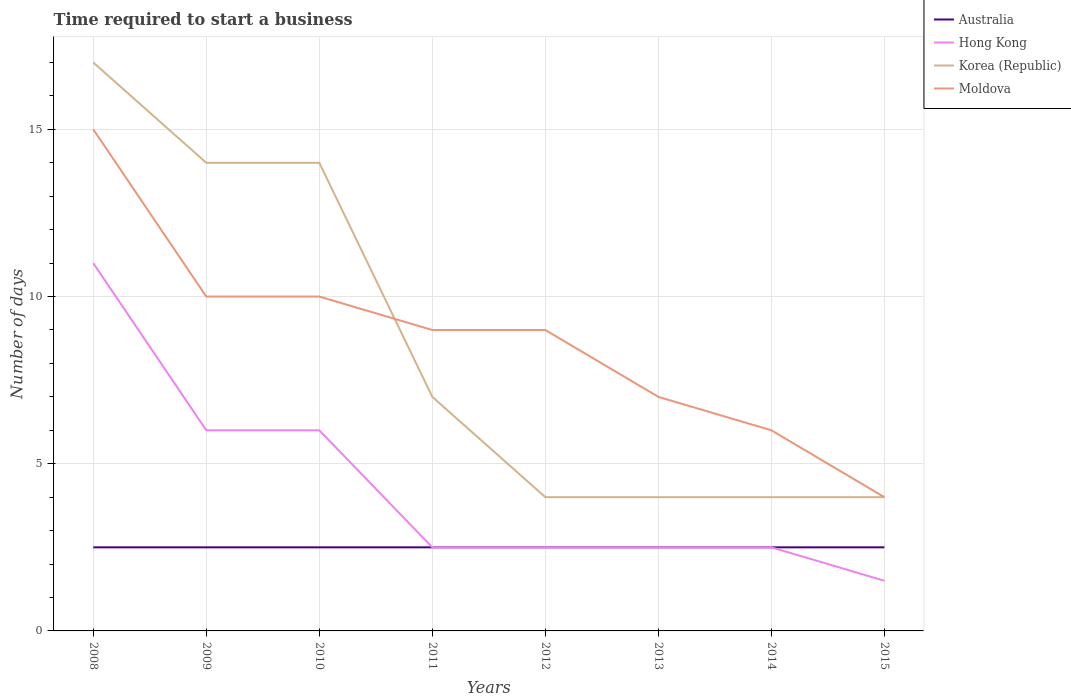Across all years, what is the maximum number of days required to start a business in Korea (Republic)?
Your response must be concise. 4. In which year was the number of days required to start a business in Hong Kong maximum?
Offer a very short reply. 2015. What is the total number of days required to start a business in Hong Kong in the graph?
Give a very brief answer. 1. What is the difference between the highest and the second highest number of days required to start a business in Moldova?
Provide a short and direct response. 11. How many lines are there?
Keep it short and to the point. 4. How many years are there in the graph?
Provide a succinct answer. 8. Are the values on the major ticks of Y-axis written in scientific E-notation?
Provide a short and direct response. No. Does the graph contain grids?
Your answer should be compact. Yes. Where does the legend appear in the graph?
Provide a short and direct response. Top right. What is the title of the graph?
Your answer should be compact. Time required to start a business. What is the label or title of the Y-axis?
Your answer should be very brief. Number of days. What is the Number of days of Australia in 2008?
Provide a short and direct response. 2.5. What is the Number of days of Korea (Republic) in 2008?
Ensure brevity in your answer.  17. What is the Number of days in Moldova in 2008?
Your answer should be very brief. 15. What is the Number of days in Korea (Republic) in 2009?
Offer a terse response. 14. What is the Number of days in Moldova in 2009?
Make the answer very short. 10. What is the Number of days in Australia in 2010?
Keep it short and to the point. 2.5. What is the Number of days of Korea (Republic) in 2010?
Keep it short and to the point. 14. What is the Number of days in Moldova in 2010?
Give a very brief answer. 10. What is the Number of days of Australia in 2011?
Offer a very short reply. 2.5. What is the Number of days in Hong Kong in 2011?
Your answer should be compact. 2.5. What is the Number of days in Korea (Republic) in 2011?
Your answer should be compact. 7. What is the Number of days in Moldova in 2011?
Make the answer very short. 9. What is the Number of days in Australia in 2012?
Make the answer very short. 2.5. What is the Number of days in Hong Kong in 2012?
Give a very brief answer. 2.5. What is the Number of days of Moldova in 2013?
Give a very brief answer. 7. What is the Number of days of Korea (Republic) in 2014?
Make the answer very short. 4. What is the Number of days of Hong Kong in 2015?
Make the answer very short. 1.5. What is the Number of days of Korea (Republic) in 2015?
Ensure brevity in your answer.  4. What is the Number of days in Moldova in 2015?
Keep it short and to the point. 4. Across all years, what is the maximum Number of days in Australia?
Your response must be concise. 2.5. Across all years, what is the maximum Number of days of Moldova?
Your answer should be compact. 15. Across all years, what is the minimum Number of days of Hong Kong?
Ensure brevity in your answer.  1.5. What is the total Number of days of Hong Kong in the graph?
Your answer should be very brief. 34.5. What is the total Number of days of Moldova in the graph?
Provide a succinct answer. 70. What is the difference between the Number of days in Moldova in 2008 and that in 2009?
Ensure brevity in your answer.  5. What is the difference between the Number of days in Korea (Republic) in 2008 and that in 2010?
Provide a succinct answer. 3. What is the difference between the Number of days in Korea (Republic) in 2008 and that in 2011?
Your answer should be compact. 10. What is the difference between the Number of days in Moldova in 2008 and that in 2011?
Your response must be concise. 6. What is the difference between the Number of days of Australia in 2008 and that in 2012?
Provide a succinct answer. 0. What is the difference between the Number of days of Moldova in 2008 and that in 2012?
Provide a succinct answer. 6. What is the difference between the Number of days of Australia in 2008 and that in 2013?
Provide a succinct answer. 0. What is the difference between the Number of days of Australia in 2008 and that in 2014?
Offer a terse response. 0. What is the difference between the Number of days in Hong Kong in 2008 and that in 2014?
Your answer should be very brief. 8.5. What is the difference between the Number of days in Korea (Republic) in 2008 and that in 2014?
Your answer should be very brief. 13. What is the difference between the Number of days of Australia in 2008 and that in 2015?
Your response must be concise. 0. What is the difference between the Number of days of Hong Kong in 2008 and that in 2015?
Make the answer very short. 9.5. What is the difference between the Number of days in Australia in 2009 and that in 2010?
Your answer should be compact. 0. What is the difference between the Number of days in Korea (Republic) in 2009 and that in 2010?
Give a very brief answer. 0. What is the difference between the Number of days in Moldova in 2009 and that in 2010?
Your answer should be compact. 0. What is the difference between the Number of days in Australia in 2009 and that in 2011?
Give a very brief answer. 0. What is the difference between the Number of days in Hong Kong in 2009 and that in 2011?
Make the answer very short. 3.5. What is the difference between the Number of days of Korea (Republic) in 2009 and that in 2011?
Offer a terse response. 7. What is the difference between the Number of days of Australia in 2009 and that in 2012?
Your response must be concise. 0. What is the difference between the Number of days of Hong Kong in 2009 and that in 2012?
Ensure brevity in your answer.  3.5. What is the difference between the Number of days of Korea (Republic) in 2009 and that in 2012?
Your answer should be very brief. 10. What is the difference between the Number of days of Hong Kong in 2009 and that in 2013?
Give a very brief answer. 3.5. What is the difference between the Number of days of Moldova in 2009 and that in 2013?
Make the answer very short. 3. What is the difference between the Number of days of Australia in 2009 and that in 2014?
Offer a terse response. 0. What is the difference between the Number of days in Korea (Republic) in 2009 and that in 2014?
Offer a very short reply. 10. What is the difference between the Number of days of Moldova in 2009 and that in 2014?
Your answer should be very brief. 4. What is the difference between the Number of days of Hong Kong in 2010 and that in 2012?
Your answer should be compact. 3.5. What is the difference between the Number of days of Moldova in 2010 and that in 2012?
Offer a terse response. 1. What is the difference between the Number of days in Korea (Republic) in 2010 and that in 2013?
Keep it short and to the point. 10. What is the difference between the Number of days in Moldova in 2010 and that in 2013?
Keep it short and to the point. 3. What is the difference between the Number of days in Australia in 2010 and that in 2014?
Your answer should be very brief. 0. What is the difference between the Number of days in Hong Kong in 2010 and that in 2014?
Your answer should be compact. 3.5. What is the difference between the Number of days of Korea (Republic) in 2010 and that in 2014?
Ensure brevity in your answer.  10. What is the difference between the Number of days in Australia in 2010 and that in 2015?
Keep it short and to the point. 0. What is the difference between the Number of days of Moldova in 2010 and that in 2015?
Your response must be concise. 6. What is the difference between the Number of days of Korea (Republic) in 2011 and that in 2013?
Provide a succinct answer. 3. What is the difference between the Number of days of Korea (Republic) in 2011 and that in 2014?
Provide a succinct answer. 3. What is the difference between the Number of days of Australia in 2011 and that in 2015?
Provide a succinct answer. 0. What is the difference between the Number of days in Hong Kong in 2011 and that in 2015?
Your response must be concise. 1. What is the difference between the Number of days of Korea (Republic) in 2011 and that in 2015?
Offer a terse response. 3. What is the difference between the Number of days of Australia in 2012 and that in 2013?
Provide a short and direct response. 0. What is the difference between the Number of days in Hong Kong in 2012 and that in 2013?
Provide a short and direct response. 0. What is the difference between the Number of days of Moldova in 2012 and that in 2013?
Your answer should be very brief. 2. What is the difference between the Number of days in Hong Kong in 2012 and that in 2014?
Your answer should be compact. 0. What is the difference between the Number of days of Korea (Republic) in 2012 and that in 2014?
Provide a succinct answer. 0. What is the difference between the Number of days of Moldova in 2012 and that in 2014?
Provide a succinct answer. 3. What is the difference between the Number of days in Korea (Republic) in 2012 and that in 2015?
Provide a succinct answer. 0. What is the difference between the Number of days in Hong Kong in 2013 and that in 2014?
Offer a terse response. 0. What is the difference between the Number of days in Korea (Republic) in 2013 and that in 2014?
Provide a succinct answer. 0. What is the difference between the Number of days of Moldova in 2013 and that in 2014?
Make the answer very short. 1. What is the difference between the Number of days in Korea (Republic) in 2013 and that in 2015?
Your response must be concise. 0. What is the difference between the Number of days of Moldova in 2013 and that in 2015?
Offer a very short reply. 3. What is the difference between the Number of days of Australia in 2014 and that in 2015?
Provide a succinct answer. 0. What is the difference between the Number of days in Korea (Republic) in 2014 and that in 2015?
Provide a succinct answer. 0. What is the difference between the Number of days of Australia in 2008 and the Number of days of Hong Kong in 2009?
Offer a very short reply. -3.5. What is the difference between the Number of days of Australia in 2008 and the Number of days of Korea (Republic) in 2009?
Offer a very short reply. -11.5. What is the difference between the Number of days of Hong Kong in 2008 and the Number of days of Moldova in 2009?
Keep it short and to the point. 1. What is the difference between the Number of days of Korea (Republic) in 2008 and the Number of days of Moldova in 2009?
Your answer should be very brief. 7. What is the difference between the Number of days of Australia in 2008 and the Number of days of Hong Kong in 2010?
Make the answer very short. -3.5. What is the difference between the Number of days in Australia in 2008 and the Number of days in Korea (Republic) in 2010?
Offer a very short reply. -11.5. What is the difference between the Number of days in Australia in 2008 and the Number of days in Moldova in 2010?
Give a very brief answer. -7.5. What is the difference between the Number of days of Hong Kong in 2008 and the Number of days of Korea (Republic) in 2010?
Provide a short and direct response. -3. What is the difference between the Number of days in Hong Kong in 2008 and the Number of days in Moldova in 2010?
Your answer should be very brief. 1. What is the difference between the Number of days in Australia in 2008 and the Number of days in Korea (Republic) in 2011?
Keep it short and to the point. -4.5. What is the difference between the Number of days in Australia in 2008 and the Number of days in Moldova in 2011?
Provide a short and direct response. -6.5. What is the difference between the Number of days of Hong Kong in 2008 and the Number of days of Korea (Republic) in 2011?
Keep it short and to the point. 4. What is the difference between the Number of days of Australia in 2008 and the Number of days of Hong Kong in 2012?
Keep it short and to the point. 0. What is the difference between the Number of days in Australia in 2008 and the Number of days in Korea (Republic) in 2012?
Give a very brief answer. -1.5. What is the difference between the Number of days of Australia in 2008 and the Number of days of Moldova in 2012?
Your answer should be compact. -6.5. What is the difference between the Number of days of Korea (Republic) in 2008 and the Number of days of Moldova in 2012?
Offer a terse response. 8. What is the difference between the Number of days of Australia in 2008 and the Number of days of Moldova in 2013?
Provide a short and direct response. -4.5. What is the difference between the Number of days in Korea (Republic) in 2008 and the Number of days in Moldova in 2013?
Give a very brief answer. 10. What is the difference between the Number of days of Australia in 2008 and the Number of days of Moldova in 2014?
Provide a short and direct response. -3.5. What is the difference between the Number of days of Hong Kong in 2008 and the Number of days of Korea (Republic) in 2014?
Make the answer very short. 7. What is the difference between the Number of days in Korea (Republic) in 2008 and the Number of days in Moldova in 2014?
Provide a short and direct response. 11. What is the difference between the Number of days of Australia in 2008 and the Number of days of Korea (Republic) in 2015?
Offer a very short reply. -1.5. What is the difference between the Number of days in Australia in 2008 and the Number of days in Moldova in 2015?
Provide a short and direct response. -1.5. What is the difference between the Number of days of Hong Kong in 2008 and the Number of days of Korea (Republic) in 2015?
Give a very brief answer. 7. What is the difference between the Number of days of Australia in 2009 and the Number of days of Hong Kong in 2010?
Offer a terse response. -3.5. What is the difference between the Number of days in Australia in 2009 and the Number of days in Korea (Republic) in 2010?
Offer a very short reply. -11.5. What is the difference between the Number of days in Hong Kong in 2009 and the Number of days in Moldova in 2010?
Your answer should be very brief. -4. What is the difference between the Number of days in Australia in 2009 and the Number of days in Moldova in 2011?
Your answer should be very brief. -6.5. What is the difference between the Number of days in Hong Kong in 2009 and the Number of days in Moldova in 2011?
Provide a succinct answer. -3. What is the difference between the Number of days in Australia in 2009 and the Number of days in Hong Kong in 2012?
Your answer should be compact. 0. What is the difference between the Number of days of Australia in 2009 and the Number of days of Korea (Republic) in 2012?
Provide a short and direct response. -1.5. What is the difference between the Number of days of Australia in 2009 and the Number of days of Moldova in 2012?
Make the answer very short. -6.5. What is the difference between the Number of days of Korea (Republic) in 2009 and the Number of days of Moldova in 2012?
Your answer should be very brief. 5. What is the difference between the Number of days of Australia in 2009 and the Number of days of Hong Kong in 2013?
Your answer should be compact. 0. What is the difference between the Number of days of Australia in 2009 and the Number of days of Korea (Republic) in 2013?
Offer a terse response. -1.5. What is the difference between the Number of days of Hong Kong in 2009 and the Number of days of Moldova in 2013?
Provide a short and direct response. -1. What is the difference between the Number of days of Korea (Republic) in 2009 and the Number of days of Moldova in 2013?
Offer a terse response. 7. What is the difference between the Number of days of Australia in 2009 and the Number of days of Moldova in 2014?
Make the answer very short. -3.5. What is the difference between the Number of days in Hong Kong in 2009 and the Number of days in Korea (Republic) in 2014?
Your answer should be very brief. 2. What is the difference between the Number of days in Hong Kong in 2009 and the Number of days in Moldova in 2014?
Your response must be concise. 0. What is the difference between the Number of days of Australia in 2009 and the Number of days of Moldova in 2015?
Keep it short and to the point. -1.5. What is the difference between the Number of days of Hong Kong in 2009 and the Number of days of Korea (Republic) in 2015?
Make the answer very short. 2. What is the difference between the Number of days in Hong Kong in 2009 and the Number of days in Moldova in 2015?
Ensure brevity in your answer.  2. What is the difference between the Number of days in Australia in 2010 and the Number of days in Hong Kong in 2011?
Keep it short and to the point. 0. What is the difference between the Number of days in Australia in 2010 and the Number of days in Korea (Republic) in 2011?
Provide a succinct answer. -4.5. What is the difference between the Number of days of Australia in 2010 and the Number of days of Moldova in 2011?
Provide a short and direct response. -6.5. What is the difference between the Number of days in Korea (Republic) in 2010 and the Number of days in Moldova in 2011?
Provide a short and direct response. 5. What is the difference between the Number of days in Australia in 2010 and the Number of days in Hong Kong in 2012?
Give a very brief answer. 0. What is the difference between the Number of days in Australia in 2010 and the Number of days in Moldova in 2012?
Provide a short and direct response. -6.5. What is the difference between the Number of days in Hong Kong in 2010 and the Number of days in Korea (Republic) in 2012?
Give a very brief answer. 2. What is the difference between the Number of days in Korea (Republic) in 2010 and the Number of days in Moldova in 2012?
Your answer should be compact. 5. What is the difference between the Number of days in Australia in 2010 and the Number of days in Hong Kong in 2013?
Your answer should be very brief. 0. What is the difference between the Number of days of Australia in 2010 and the Number of days of Korea (Republic) in 2013?
Provide a short and direct response. -1.5. What is the difference between the Number of days of Hong Kong in 2010 and the Number of days of Moldova in 2013?
Your answer should be compact. -1. What is the difference between the Number of days in Korea (Republic) in 2010 and the Number of days in Moldova in 2013?
Your answer should be very brief. 7. What is the difference between the Number of days in Australia in 2010 and the Number of days in Korea (Republic) in 2015?
Your response must be concise. -1.5. What is the difference between the Number of days of Australia in 2010 and the Number of days of Moldova in 2015?
Offer a very short reply. -1.5. What is the difference between the Number of days in Australia in 2011 and the Number of days in Hong Kong in 2012?
Your answer should be very brief. 0. What is the difference between the Number of days in Korea (Republic) in 2011 and the Number of days in Moldova in 2012?
Offer a very short reply. -2. What is the difference between the Number of days in Australia in 2011 and the Number of days in Hong Kong in 2013?
Offer a terse response. 0. What is the difference between the Number of days of Hong Kong in 2011 and the Number of days of Moldova in 2013?
Your answer should be compact. -4.5. What is the difference between the Number of days of Australia in 2011 and the Number of days of Moldova in 2014?
Offer a terse response. -3.5. What is the difference between the Number of days in Korea (Republic) in 2011 and the Number of days in Moldova in 2014?
Your answer should be very brief. 1. What is the difference between the Number of days in Australia in 2011 and the Number of days in Hong Kong in 2015?
Give a very brief answer. 1. What is the difference between the Number of days of Australia in 2011 and the Number of days of Korea (Republic) in 2015?
Provide a short and direct response. -1.5. What is the difference between the Number of days of Australia in 2011 and the Number of days of Moldova in 2015?
Your answer should be very brief. -1.5. What is the difference between the Number of days of Hong Kong in 2011 and the Number of days of Korea (Republic) in 2015?
Keep it short and to the point. -1.5. What is the difference between the Number of days of Korea (Republic) in 2011 and the Number of days of Moldova in 2015?
Make the answer very short. 3. What is the difference between the Number of days of Australia in 2012 and the Number of days of Hong Kong in 2013?
Make the answer very short. 0. What is the difference between the Number of days of Hong Kong in 2012 and the Number of days of Korea (Republic) in 2013?
Your answer should be compact. -1.5. What is the difference between the Number of days in Korea (Republic) in 2012 and the Number of days in Moldova in 2013?
Make the answer very short. -3. What is the difference between the Number of days of Australia in 2012 and the Number of days of Hong Kong in 2014?
Keep it short and to the point. 0. What is the difference between the Number of days of Australia in 2012 and the Number of days of Moldova in 2014?
Offer a very short reply. -3.5. What is the difference between the Number of days of Hong Kong in 2012 and the Number of days of Korea (Republic) in 2014?
Offer a terse response. -1.5. What is the difference between the Number of days in Australia in 2012 and the Number of days in Hong Kong in 2015?
Your answer should be very brief. 1. What is the difference between the Number of days of Australia in 2012 and the Number of days of Korea (Republic) in 2015?
Offer a very short reply. -1.5. What is the difference between the Number of days in Hong Kong in 2012 and the Number of days in Moldova in 2015?
Ensure brevity in your answer.  -1.5. What is the difference between the Number of days of Korea (Republic) in 2012 and the Number of days of Moldova in 2015?
Provide a short and direct response. 0. What is the difference between the Number of days of Hong Kong in 2013 and the Number of days of Korea (Republic) in 2014?
Ensure brevity in your answer.  -1.5. What is the difference between the Number of days in Korea (Republic) in 2013 and the Number of days in Moldova in 2014?
Provide a short and direct response. -2. What is the difference between the Number of days in Australia in 2013 and the Number of days in Korea (Republic) in 2015?
Provide a succinct answer. -1.5. What is the difference between the Number of days in Australia in 2014 and the Number of days in Korea (Republic) in 2015?
Offer a terse response. -1.5. What is the difference between the Number of days in Australia in 2014 and the Number of days in Moldova in 2015?
Give a very brief answer. -1.5. What is the difference between the Number of days in Hong Kong in 2014 and the Number of days in Korea (Republic) in 2015?
Provide a succinct answer. -1.5. What is the difference between the Number of days of Korea (Republic) in 2014 and the Number of days of Moldova in 2015?
Your answer should be very brief. 0. What is the average Number of days in Hong Kong per year?
Keep it short and to the point. 4.31. What is the average Number of days of Korea (Republic) per year?
Your response must be concise. 8.5. What is the average Number of days in Moldova per year?
Offer a very short reply. 8.75. In the year 2008, what is the difference between the Number of days in Australia and Number of days in Moldova?
Offer a very short reply. -12.5. In the year 2009, what is the difference between the Number of days of Australia and Number of days of Korea (Republic)?
Keep it short and to the point. -11.5. In the year 2009, what is the difference between the Number of days in Hong Kong and Number of days in Korea (Republic)?
Offer a terse response. -8. In the year 2009, what is the difference between the Number of days in Hong Kong and Number of days in Moldova?
Your answer should be compact. -4. In the year 2010, what is the difference between the Number of days in Australia and Number of days in Hong Kong?
Ensure brevity in your answer.  -3.5. In the year 2010, what is the difference between the Number of days in Australia and Number of days in Korea (Republic)?
Provide a succinct answer. -11.5. In the year 2010, what is the difference between the Number of days of Australia and Number of days of Moldova?
Provide a short and direct response. -7.5. In the year 2010, what is the difference between the Number of days of Hong Kong and Number of days of Korea (Republic)?
Ensure brevity in your answer.  -8. In the year 2010, what is the difference between the Number of days in Hong Kong and Number of days in Moldova?
Ensure brevity in your answer.  -4. In the year 2010, what is the difference between the Number of days of Korea (Republic) and Number of days of Moldova?
Provide a short and direct response. 4. In the year 2011, what is the difference between the Number of days of Australia and Number of days of Korea (Republic)?
Keep it short and to the point. -4.5. In the year 2011, what is the difference between the Number of days in Australia and Number of days in Moldova?
Make the answer very short. -6.5. In the year 2011, what is the difference between the Number of days of Hong Kong and Number of days of Korea (Republic)?
Your answer should be compact. -4.5. In the year 2011, what is the difference between the Number of days of Korea (Republic) and Number of days of Moldova?
Your answer should be very brief. -2. In the year 2012, what is the difference between the Number of days of Australia and Number of days of Hong Kong?
Provide a short and direct response. 0. In the year 2012, what is the difference between the Number of days of Australia and Number of days of Korea (Republic)?
Offer a terse response. -1.5. In the year 2012, what is the difference between the Number of days in Hong Kong and Number of days in Korea (Republic)?
Provide a succinct answer. -1.5. In the year 2012, what is the difference between the Number of days in Hong Kong and Number of days in Moldova?
Offer a terse response. -6.5. In the year 2012, what is the difference between the Number of days of Korea (Republic) and Number of days of Moldova?
Make the answer very short. -5. In the year 2013, what is the difference between the Number of days in Australia and Number of days in Korea (Republic)?
Give a very brief answer. -1.5. In the year 2013, what is the difference between the Number of days in Hong Kong and Number of days in Korea (Republic)?
Provide a short and direct response. -1.5. In the year 2013, what is the difference between the Number of days in Korea (Republic) and Number of days in Moldova?
Offer a terse response. -3. In the year 2014, what is the difference between the Number of days of Australia and Number of days of Korea (Republic)?
Give a very brief answer. -1.5. In the year 2014, what is the difference between the Number of days in Australia and Number of days in Moldova?
Your answer should be compact. -3.5. In the year 2014, what is the difference between the Number of days in Hong Kong and Number of days in Moldova?
Your answer should be compact. -3.5. In the year 2015, what is the difference between the Number of days in Australia and Number of days in Hong Kong?
Your answer should be compact. 1. In the year 2015, what is the difference between the Number of days of Australia and Number of days of Moldova?
Give a very brief answer. -1.5. In the year 2015, what is the difference between the Number of days in Hong Kong and Number of days in Korea (Republic)?
Offer a terse response. -2.5. What is the ratio of the Number of days in Hong Kong in 2008 to that in 2009?
Your response must be concise. 1.83. What is the ratio of the Number of days of Korea (Republic) in 2008 to that in 2009?
Provide a succinct answer. 1.21. What is the ratio of the Number of days of Moldova in 2008 to that in 2009?
Your answer should be very brief. 1.5. What is the ratio of the Number of days in Hong Kong in 2008 to that in 2010?
Ensure brevity in your answer.  1.83. What is the ratio of the Number of days in Korea (Republic) in 2008 to that in 2010?
Give a very brief answer. 1.21. What is the ratio of the Number of days in Korea (Republic) in 2008 to that in 2011?
Make the answer very short. 2.43. What is the ratio of the Number of days in Moldova in 2008 to that in 2011?
Give a very brief answer. 1.67. What is the ratio of the Number of days in Australia in 2008 to that in 2012?
Give a very brief answer. 1. What is the ratio of the Number of days in Korea (Republic) in 2008 to that in 2012?
Keep it short and to the point. 4.25. What is the ratio of the Number of days of Australia in 2008 to that in 2013?
Your answer should be compact. 1. What is the ratio of the Number of days in Hong Kong in 2008 to that in 2013?
Make the answer very short. 4.4. What is the ratio of the Number of days in Korea (Republic) in 2008 to that in 2013?
Your answer should be compact. 4.25. What is the ratio of the Number of days in Moldova in 2008 to that in 2013?
Ensure brevity in your answer.  2.14. What is the ratio of the Number of days in Australia in 2008 to that in 2014?
Provide a succinct answer. 1. What is the ratio of the Number of days of Hong Kong in 2008 to that in 2014?
Offer a terse response. 4.4. What is the ratio of the Number of days of Korea (Republic) in 2008 to that in 2014?
Give a very brief answer. 4.25. What is the ratio of the Number of days in Moldova in 2008 to that in 2014?
Your answer should be compact. 2.5. What is the ratio of the Number of days in Hong Kong in 2008 to that in 2015?
Your response must be concise. 7.33. What is the ratio of the Number of days in Korea (Republic) in 2008 to that in 2015?
Your response must be concise. 4.25. What is the ratio of the Number of days of Moldova in 2008 to that in 2015?
Provide a succinct answer. 3.75. What is the ratio of the Number of days in Australia in 2009 to that in 2010?
Offer a very short reply. 1. What is the ratio of the Number of days in Hong Kong in 2009 to that in 2010?
Ensure brevity in your answer.  1. What is the ratio of the Number of days in Korea (Republic) in 2009 to that in 2010?
Your answer should be very brief. 1. What is the ratio of the Number of days of Korea (Republic) in 2009 to that in 2011?
Make the answer very short. 2. What is the ratio of the Number of days of Moldova in 2009 to that in 2011?
Your answer should be compact. 1.11. What is the ratio of the Number of days in Australia in 2009 to that in 2012?
Provide a short and direct response. 1. What is the ratio of the Number of days of Hong Kong in 2009 to that in 2012?
Offer a very short reply. 2.4. What is the ratio of the Number of days in Moldova in 2009 to that in 2012?
Provide a succinct answer. 1.11. What is the ratio of the Number of days in Australia in 2009 to that in 2013?
Ensure brevity in your answer.  1. What is the ratio of the Number of days of Hong Kong in 2009 to that in 2013?
Ensure brevity in your answer.  2.4. What is the ratio of the Number of days of Korea (Republic) in 2009 to that in 2013?
Offer a terse response. 3.5. What is the ratio of the Number of days of Moldova in 2009 to that in 2013?
Your response must be concise. 1.43. What is the ratio of the Number of days of Australia in 2009 to that in 2014?
Make the answer very short. 1. What is the ratio of the Number of days in Hong Kong in 2009 to that in 2014?
Offer a very short reply. 2.4. What is the ratio of the Number of days in Moldova in 2009 to that in 2014?
Ensure brevity in your answer.  1.67. What is the ratio of the Number of days in Australia in 2009 to that in 2015?
Make the answer very short. 1. What is the ratio of the Number of days of Hong Kong in 2009 to that in 2015?
Give a very brief answer. 4. What is the ratio of the Number of days in Korea (Republic) in 2009 to that in 2015?
Provide a short and direct response. 3.5. What is the ratio of the Number of days in Korea (Republic) in 2010 to that in 2011?
Keep it short and to the point. 2. What is the ratio of the Number of days of Moldova in 2010 to that in 2011?
Offer a very short reply. 1.11. What is the ratio of the Number of days in Australia in 2010 to that in 2012?
Provide a short and direct response. 1. What is the ratio of the Number of days in Korea (Republic) in 2010 to that in 2012?
Keep it short and to the point. 3.5. What is the ratio of the Number of days in Moldova in 2010 to that in 2012?
Your response must be concise. 1.11. What is the ratio of the Number of days in Korea (Republic) in 2010 to that in 2013?
Offer a very short reply. 3.5. What is the ratio of the Number of days of Moldova in 2010 to that in 2013?
Offer a terse response. 1.43. What is the ratio of the Number of days of Korea (Republic) in 2010 to that in 2014?
Ensure brevity in your answer.  3.5. What is the ratio of the Number of days in Korea (Republic) in 2010 to that in 2015?
Provide a succinct answer. 3.5. What is the ratio of the Number of days in Moldova in 2010 to that in 2015?
Provide a short and direct response. 2.5. What is the ratio of the Number of days in Australia in 2011 to that in 2012?
Offer a terse response. 1. What is the ratio of the Number of days of Hong Kong in 2011 to that in 2012?
Your answer should be very brief. 1. What is the ratio of the Number of days in Korea (Republic) in 2011 to that in 2012?
Your response must be concise. 1.75. What is the ratio of the Number of days of Australia in 2011 to that in 2013?
Offer a terse response. 1. What is the ratio of the Number of days of Korea (Republic) in 2011 to that in 2014?
Make the answer very short. 1.75. What is the ratio of the Number of days in Australia in 2011 to that in 2015?
Provide a succinct answer. 1. What is the ratio of the Number of days in Korea (Republic) in 2011 to that in 2015?
Offer a terse response. 1.75. What is the ratio of the Number of days in Moldova in 2011 to that in 2015?
Provide a short and direct response. 2.25. What is the ratio of the Number of days in Hong Kong in 2012 to that in 2014?
Your answer should be very brief. 1. What is the ratio of the Number of days of Korea (Republic) in 2012 to that in 2014?
Offer a terse response. 1. What is the ratio of the Number of days of Moldova in 2012 to that in 2014?
Your answer should be very brief. 1.5. What is the ratio of the Number of days in Australia in 2012 to that in 2015?
Your answer should be very brief. 1. What is the ratio of the Number of days of Hong Kong in 2012 to that in 2015?
Keep it short and to the point. 1.67. What is the ratio of the Number of days in Moldova in 2012 to that in 2015?
Make the answer very short. 2.25. What is the ratio of the Number of days in Hong Kong in 2013 to that in 2014?
Your answer should be compact. 1. What is the ratio of the Number of days in Korea (Republic) in 2013 to that in 2015?
Keep it short and to the point. 1. What is the ratio of the Number of days in Moldova in 2013 to that in 2015?
Your response must be concise. 1.75. What is the ratio of the Number of days in Australia in 2014 to that in 2015?
Make the answer very short. 1. What is the ratio of the Number of days in Hong Kong in 2014 to that in 2015?
Provide a succinct answer. 1.67. What is the ratio of the Number of days of Korea (Republic) in 2014 to that in 2015?
Your response must be concise. 1. What is the difference between the highest and the second highest Number of days in Australia?
Give a very brief answer. 0. What is the difference between the highest and the second highest Number of days of Hong Kong?
Offer a very short reply. 5. What is the difference between the highest and the lowest Number of days in Korea (Republic)?
Keep it short and to the point. 13. What is the difference between the highest and the lowest Number of days of Moldova?
Your answer should be very brief. 11. 